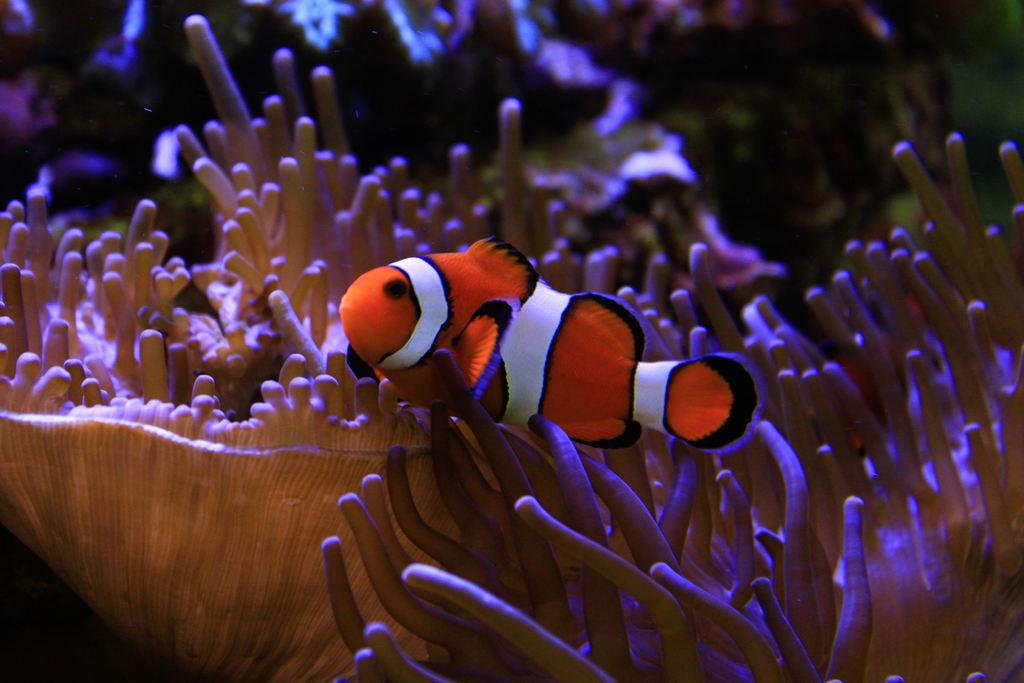What type of picture is the image? The image is an animated picture. What is the main subject in the image? There is a fish in the middle of the image. What else can be seen at the bottom of the image? There are water plants at the bottom of the image. Where is the image set? The image is set inside water. What type of education can be seen being provided to the fish in the image? There is no education being provided to the fish in the image; it is an animated picture of a fish in water with water plants. How many eggs are visible in the image? There are no eggs visible in the image. 